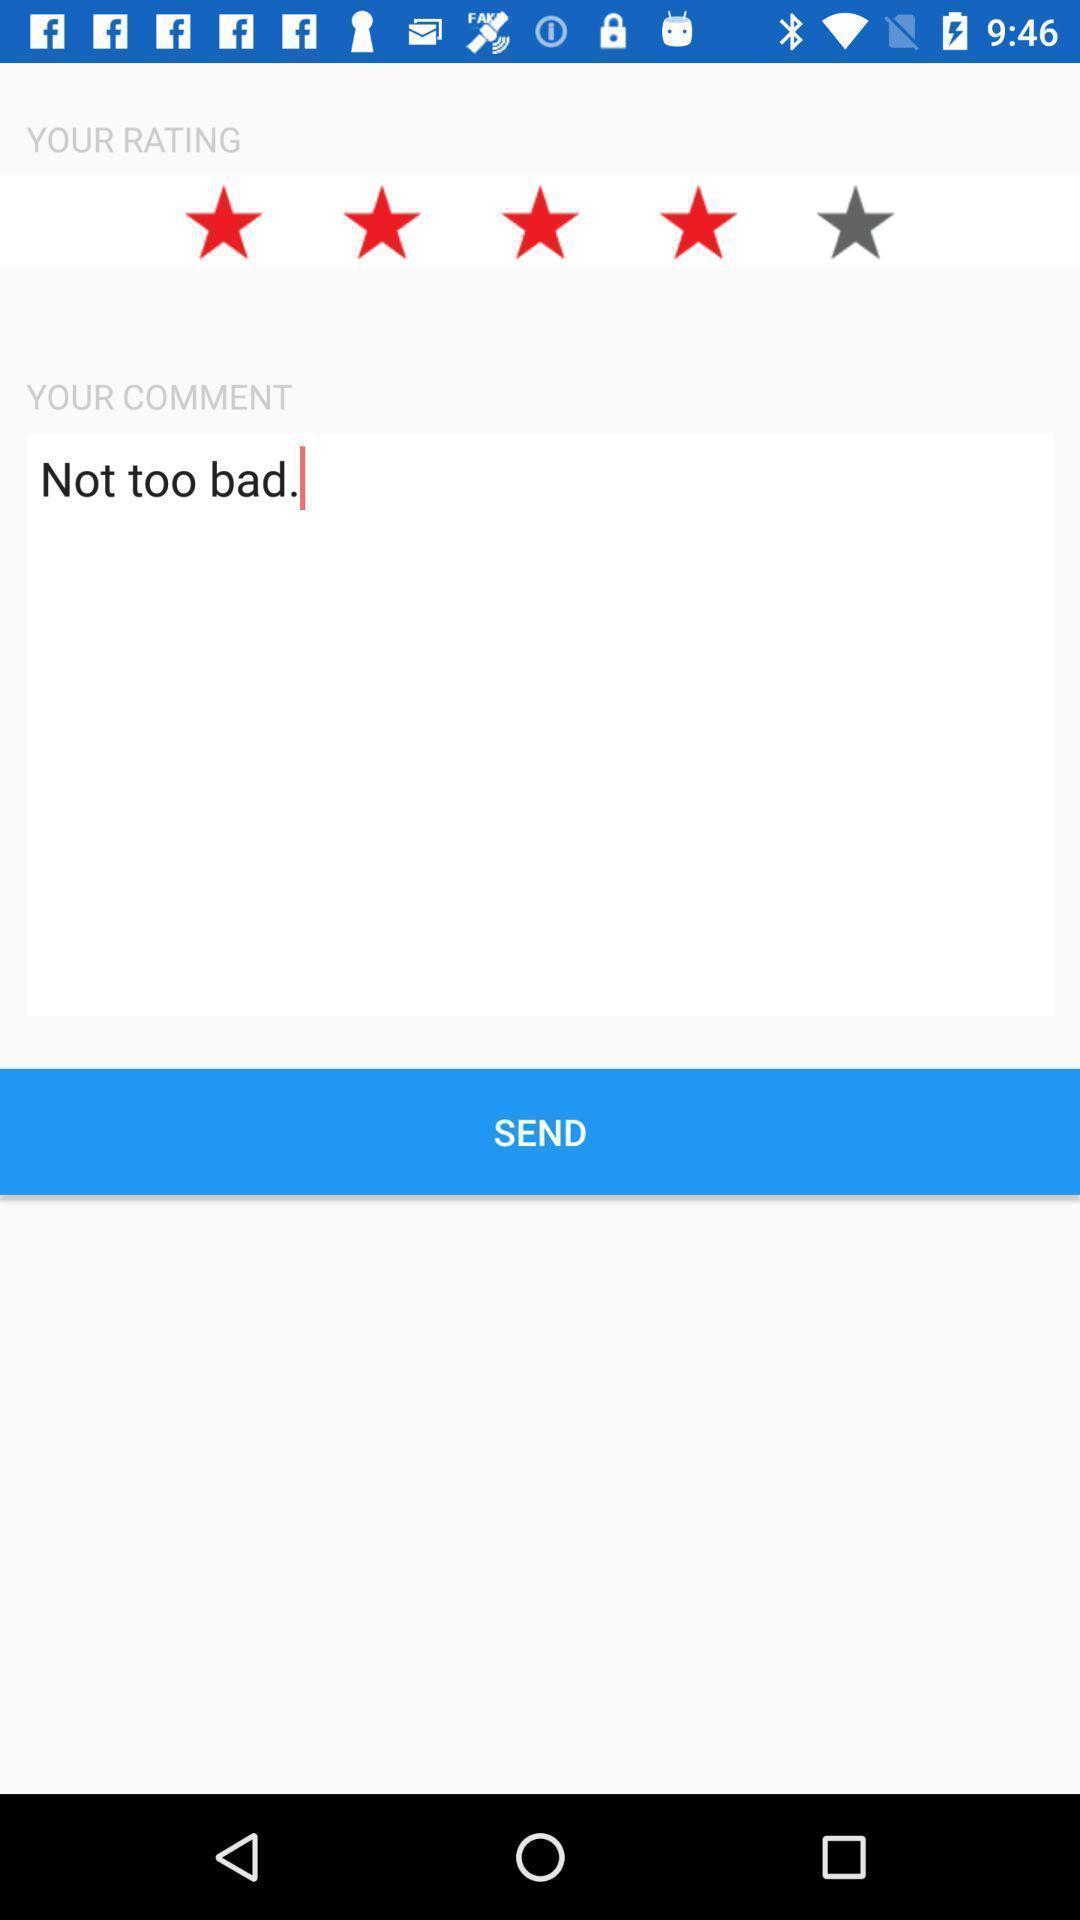Explain what's happening in this screen capture. Page shows to send your feedback. 